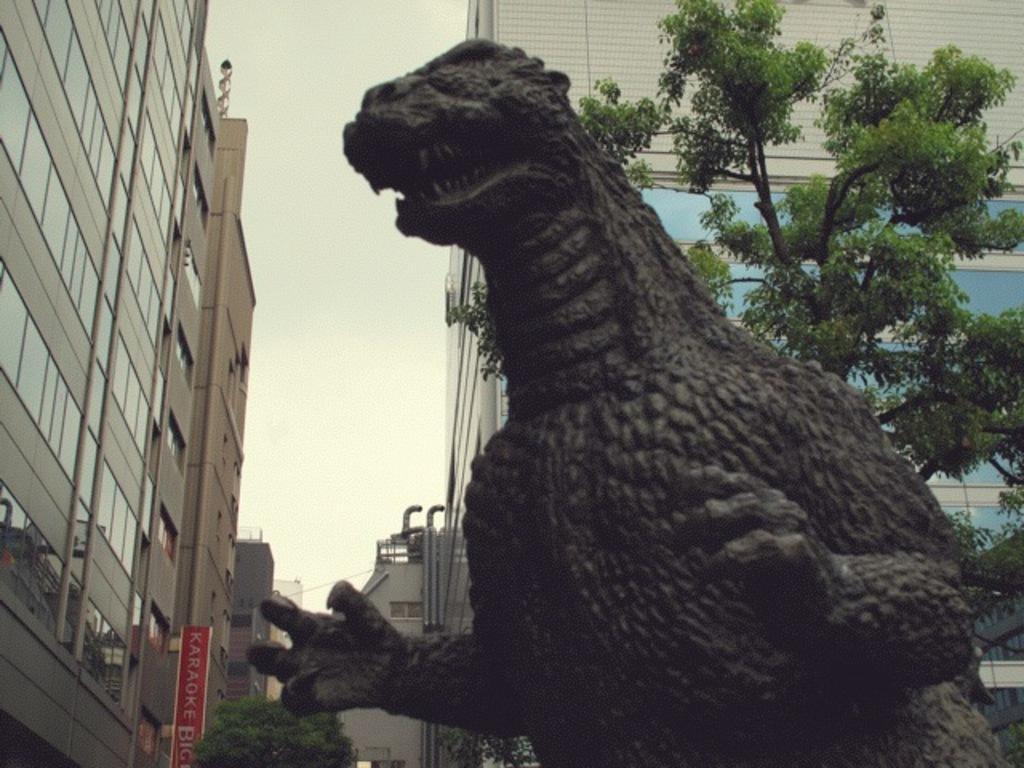Could you give a brief overview of what you see in this image? In this image we can see a black color dinosaur statue. Behind trees and buildings are present. 